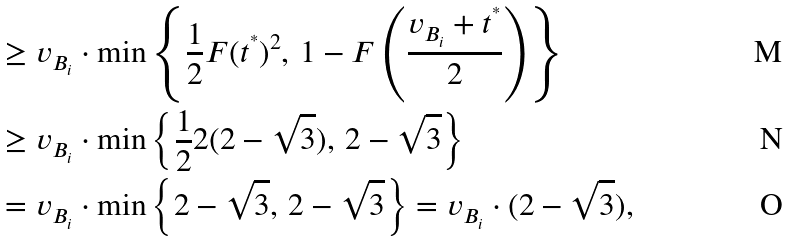Convert formula to latex. <formula><loc_0><loc_0><loc_500><loc_500>& \geq v _ { B _ { i } } \cdot \min \left \{ \frac { 1 } { 2 } F ( t ^ { ^ { * } } ) ^ { 2 } , \, 1 - F \left ( \frac { v _ { B _ { i } } + t ^ { ^ { * } } } { 2 } \right ) \right \} \\ & \geq v _ { B _ { i } } \cdot \min \left \{ \frac { 1 } { 2 } 2 ( 2 - \sqrt { 3 } ) , \, 2 - \sqrt { 3 } \right \} \\ & = v _ { B _ { i } } \cdot \min \left \{ 2 - \sqrt { 3 } , \, 2 - \sqrt { 3 } \right \} = v _ { B _ { i } } \cdot ( 2 - \sqrt { 3 } ) ,</formula> 